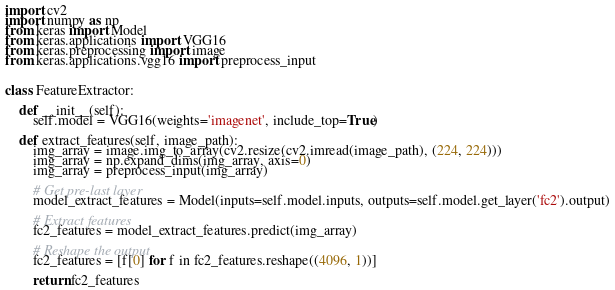Convert code to text. <code><loc_0><loc_0><loc_500><loc_500><_Python_>import cv2
import numpy as np
from keras import Model
from keras.applications import VGG16
from keras.preprocessing import image
from keras.applications.vgg16 import preprocess_input


class FeatureExtractor:

    def __init__(self):
        self.model = VGG16(weights='imagenet', include_top=True)

    def extract_features(self, image_path):
        img_array = image.img_to_array(cv2.resize(cv2.imread(image_path), (224, 224)))
        img_array = np.expand_dims(img_array, axis=0)
        img_array = preprocess_input(img_array)

        # Get pre-last layer
        model_extract_features = Model(inputs=self.model.inputs, outputs=self.model.get_layer('fc2').output)

        # Extract features
        fc2_features = model_extract_features.predict(img_array)

        # Reshape the output
        fc2_features = [f[0] for f in fc2_features.reshape((4096, 1))]

        return fc2_features
</code> 